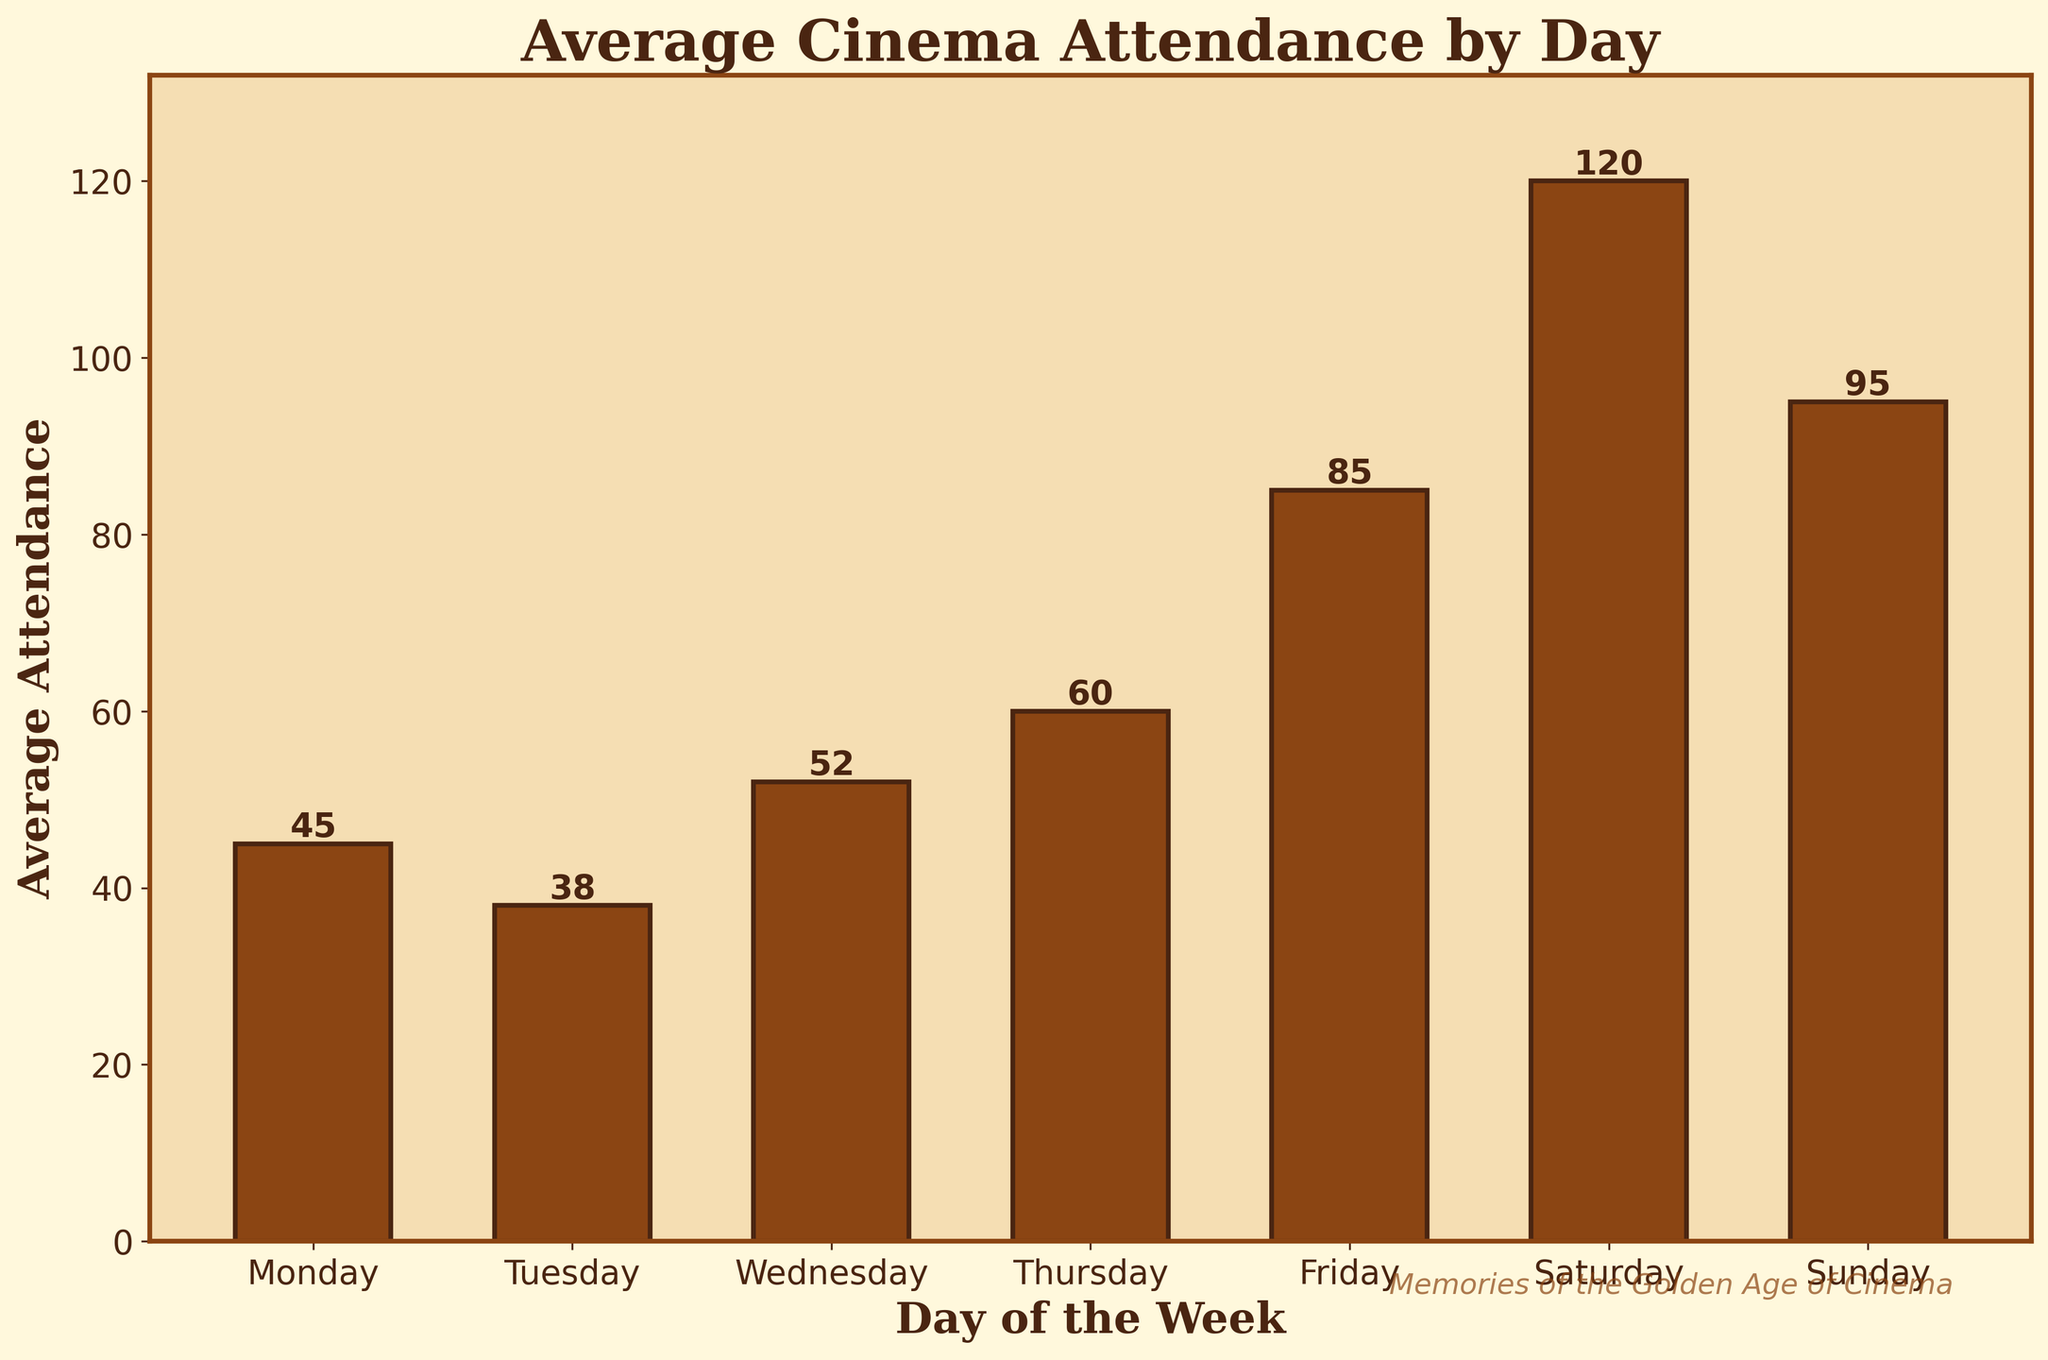What's the most attended day of the week? The bar representing Saturday is the tallest, indicating that Saturday has the highest average attendance among all the days shown in the chart.
Answer: Saturday Which day has the least average attendance? The bar representing Tuesday is the shortest, indicating that Tuesday has the lowest average attendance among all the days shown in the chart.
Answer: Tuesday How much more is the average attendance on Sunday compared to Monday? The attendance on Sunday is 95, and on Monday, it is 45. The difference is 95 - 45.
Answer: 50 What is the difference in average attendance between the highest and lowest attended days? The highest attendance is on Saturday with 120, and the lowest attendance is on Tuesday with 38. The difference is 120 - 38.
Answer: 82 On which day does the average attendance exceed 50 by the greatest margin? On Saturday and Sunday the average attendance exceeds 50 significantly. For Saturday: 120 - 50 = 70, and for Sunday: 95 - 50 = 45. Hence, Saturday exceeds 50 by the greatest margin.
Answer: Saturday What is the combined average attendance for the weekend (Saturday and Sunday)? The average attendance on Saturday is 120, and on Sunday, it is 95. The combined average attendance is 120 + 95.
Answer: 215 Is the average attendance more on Friday or on Thursday? The bar representing Friday is taller than the bar representing Thursday. Therefore, the average attendance on Friday (85) is more than on Thursday (60).
Answer: Friday What is the average attendance on Wednesday and Thursday combined? The attendance on Wednesday is 52, while on Thursday, it is 60. The combined total is 52 + 60, and the average is (52 + 60) / 2.
Answer: 56 Do more people attend the cinema on weekdays (Monday to Friday) or weekends (Saturday and Sunday)? Weekdays’ total attendance is: 45 (Mon) + 38 (Tue) + 52 (Wed) + 60 (Thu) + 85 (Fri) = 280. Weekends’ total attendance is: 120 (Sat) + 95 (Sun) = 215. Therefore, more people attend on weekdays.
Answer: Weekdays If we consider Monday and Tuesday as the beginning of the week and Friday as part of the weekend, what would be the average attendance for these three days? The average attendance for Monday is 45, for Tuesday is 38, and for Friday is 85. The combined total attendance is 45 + 38 + 85 = 168, and the average would be 168 / 3.
Answer: 56 